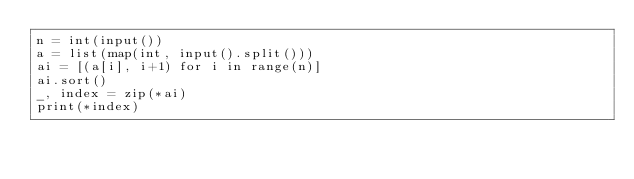Convert code to text. <code><loc_0><loc_0><loc_500><loc_500><_Python_>n = int(input())
a = list(map(int, input().split()))
ai = [(a[i], i+1) for i in range(n)]
ai.sort()
_, index = zip(*ai)
print(*index)
</code> 